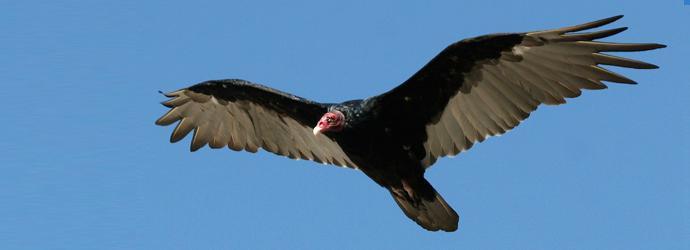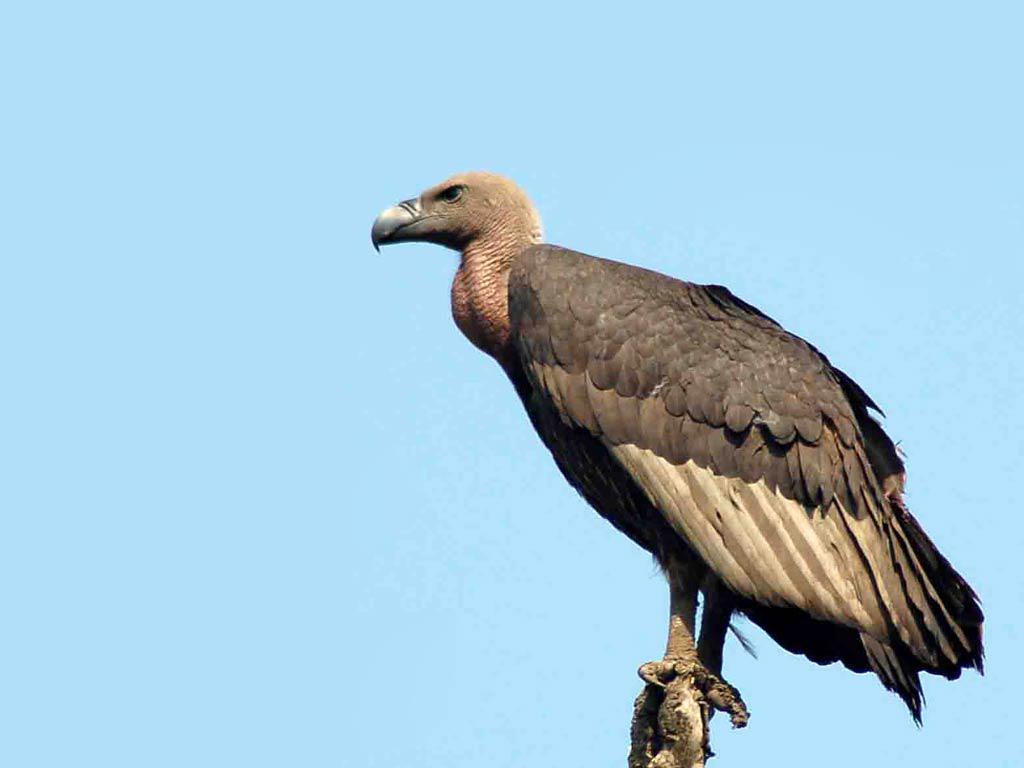The first image is the image on the left, the second image is the image on the right. Given the left and right images, does the statement "a vulture is flying with wings spread wide" hold true? Answer yes or no. Yes. The first image is the image on the left, the second image is the image on the right. For the images displayed, is the sentence "In the left image, a bird is flying." factually correct? Answer yes or no. Yes. 